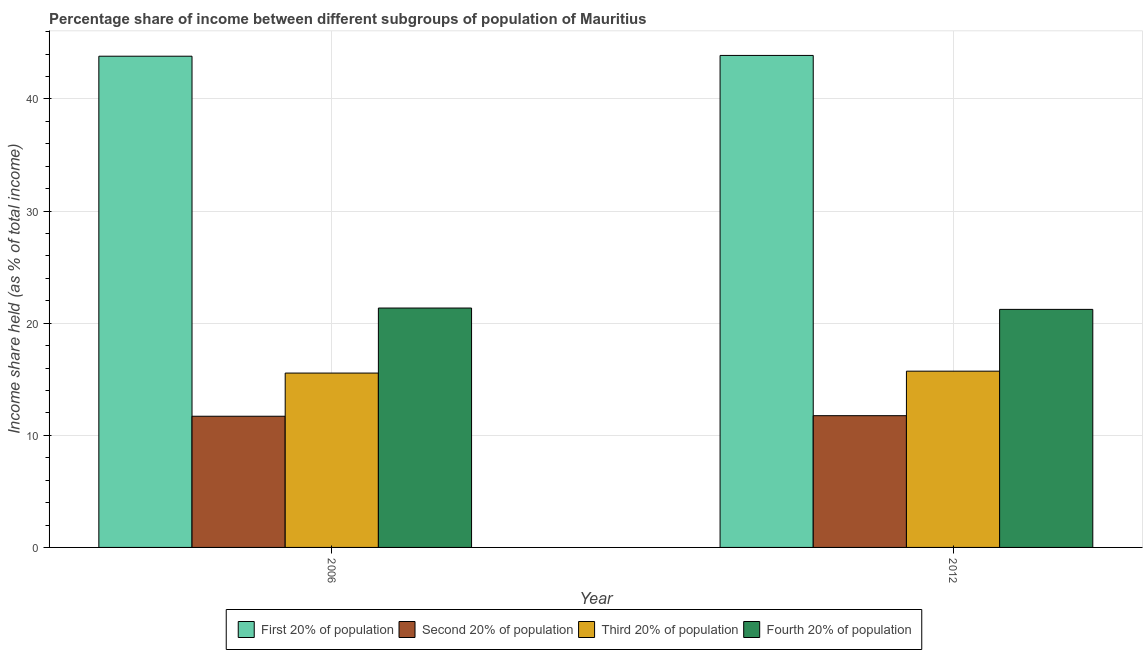How many different coloured bars are there?
Offer a terse response. 4. What is the label of the 1st group of bars from the left?
Provide a succinct answer. 2006. What is the share of the income held by first 20% of the population in 2012?
Keep it short and to the point. 43.88. Across all years, what is the maximum share of the income held by first 20% of the population?
Your response must be concise. 43.88. Across all years, what is the minimum share of the income held by fourth 20% of the population?
Your answer should be very brief. 21.23. In which year was the share of the income held by second 20% of the population maximum?
Offer a terse response. 2012. In which year was the share of the income held by fourth 20% of the population minimum?
Your response must be concise. 2012. What is the total share of the income held by first 20% of the population in the graph?
Offer a very short reply. 87.69. What is the difference between the share of the income held by first 20% of the population in 2006 and that in 2012?
Your answer should be compact. -0.07. What is the difference between the share of the income held by fourth 20% of the population in 2012 and the share of the income held by third 20% of the population in 2006?
Your answer should be compact. -0.12. What is the average share of the income held by second 20% of the population per year?
Ensure brevity in your answer.  11.72. In the year 2012, what is the difference between the share of the income held by second 20% of the population and share of the income held by first 20% of the population?
Keep it short and to the point. 0. In how many years, is the share of the income held by third 20% of the population greater than 34 %?
Your answer should be compact. 0. What is the ratio of the share of the income held by second 20% of the population in 2006 to that in 2012?
Keep it short and to the point. 1. In how many years, is the share of the income held by third 20% of the population greater than the average share of the income held by third 20% of the population taken over all years?
Offer a terse response. 1. Is it the case that in every year, the sum of the share of the income held by fourth 20% of the population and share of the income held by third 20% of the population is greater than the sum of share of the income held by first 20% of the population and share of the income held by second 20% of the population?
Ensure brevity in your answer.  No. What does the 4th bar from the left in 2006 represents?
Offer a terse response. Fourth 20% of population. What does the 2nd bar from the right in 2012 represents?
Make the answer very short. Third 20% of population. How many bars are there?
Provide a short and direct response. 8. Does the graph contain grids?
Your response must be concise. Yes. Where does the legend appear in the graph?
Provide a succinct answer. Bottom center. How many legend labels are there?
Provide a succinct answer. 4. How are the legend labels stacked?
Give a very brief answer. Horizontal. What is the title of the graph?
Keep it short and to the point. Percentage share of income between different subgroups of population of Mauritius. What is the label or title of the Y-axis?
Keep it short and to the point. Income share held (as % of total income). What is the Income share held (as % of total income) in First 20% of population in 2006?
Ensure brevity in your answer.  43.81. What is the Income share held (as % of total income) in Third 20% of population in 2006?
Give a very brief answer. 15.55. What is the Income share held (as % of total income) of Fourth 20% of population in 2006?
Provide a succinct answer. 21.35. What is the Income share held (as % of total income) in First 20% of population in 2012?
Offer a terse response. 43.88. What is the Income share held (as % of total income) of Second 20% of population in 2012?
Provide a short and direct response. 11.75. What is the Income share held (as % of total income) in Third 20% of population in 2012?
Offer a very short reply. 15.72. What is the Income share held (as % of total income) in Fourth 20% of population in 2012?
Provide a short and direct response. 21.23. Across all years, what is the maximum Income share held (as % of total income) of First 20% of population?
Make the answer very short. 43.88. Across all years, what is the maximum Income share held (as % of total income) of Second 20% of population?
Provide a short and direct response. 11.75. Across all years, what is the maximum Income share held (as % of total income) in Third 20% of population?
Offer a very short reply. 15.72. Across all years, what is the maximum Income share held (as % of total income) in Fourth 20% of population?
Provide a succinct answer. 21.35. Across all years, what is the minimum Income share held (as % of total income) in First 20% of population?
Offer a terse response. 43.81. Across all years, what is the minimum Income share held (as % of total income) in Third 20% of population?
Make the answer very short. 15.55. Across all years, what is the minimum Income share held (as % of total income) of Fourth 20% of population?
Your answer should be very brief. 21.23. What is the total Income share held (as % of total income) in First 20% of population in the graph?
Your answer should be very brief. 87.69. What is the total Income share held (as % of total income) of Second 20% of population in the graph?
Provide a succinct answer. 23.45. What is the total Income share held (as % of total income) in Third 20% of population in the graph?
Make the answer very short. 31.27. What is the total Income share held (as % of total income) of Fourth 20% of population in the graph?
Your answer should be compact. 42.58. What is the difference between the Income share held (as % of total income) in First 20% of population in 2006 and that in 2012?
Offer a very short reply. -0.07. What is the difference between the Income share held (as % of total income) in Third 20% of population in 2006 and that in 2012?
Your answer should be very brief. -0.17. What is the difference between the Income share held (as % of total income) in Fourth 20% of population in 2006 and that in 2012?
Make the answer very short. 0.12. What is the difference between the Income share held (as % of total income) in First 20% of population in 2006 and the Income share held (as % of total income) in Second 20% of population in 2012?
Your answer should be compact. 32.06. What is the difference between the Income share held (as % of total income) of First 20% of population in 2006 and the Income share held (as % of total income) of Third 20% of population in 2012?
Your answer should be very brief. 28.09. What is the difference between the Income share held (as % of total income) in First 20% of population in 2006 and the Income share held (as % of total income) in Fourth 20% of population in 2012?
Offer a terse response. 22.58. What is the difference between the Income share held (as % of total income) in Second 20% of population in 2006 and the Income share held (as % of total income) in Third 20% of population in 2012?
Provide a succinct answer. -4.02. What is the difference between the Income share held (as % of total income) of Second 20% of population in 2006 and the Income share held (as % of total income) of Fourth 20% of population in 2012?
Keep it short and to the point. -9.53. What is the difference between the Income share held (as % of total income) of Third 20% of population in 2006 and the Income share held (as % of total income) of Fourth 20% of population in 2012?
Provide a succinct answer. -5.68. What is the average Income share held (as % of total income) of First 20% of population per year?
Your response must be concise. 43.84. What is the average Income share held (as % of total income) of Second 20% of population per year?
Make the answer very short. 11.72. What is the average Income share held (as % of total income) of Third 20% of population per year?
Ensure brevity in your answer.  15.63. What is the average Income share held (as % of total income) of Fourth 20% of population per year?
Ensure brevity in your answer.  21.29. In the year 2006, what is the difference between the Income share held (as % of total income) of First 20% of population and Income share held (as % of total income) of Second 20% of population?
Ensure brevity in your answer.  32.11. In the year 2006, what is the difference between the Income share held (as % of total income) of First 20% of population and Income share held (as % of total income) of Third 20% of population?
Offer a terse response. 28.26. In the year 2006, what is the difference between the Income share held (as % of total income) of First 20% of population and Income share held (as % of total income) of Fourth 20% of population?
Provide a short and direct response. 22.46. In the year 2006, what is the difference between the Income share held (as % of total income) in Second 20% of population and Income share held (as % of total income) in Third 20% of population?
Provide a short and direct response. -3.85. In the year 2006, what is the difference between the Income share held (as % of total income) of Second 20% of population and Income share held (as % of total income) of Fourth 20% of population?
Give a very brief answer. -9.65. In the year 2006, what is the difference between the Income share held (as % of total income) in Third 20% of population and Income share held (as % of total income) in Fourth 20% of population?
Your response must be concise. -5.8. In the year 2012, what is the difference between the Income share held (as % of total income) of First 20% of population and Income share held (as % of total income) of Second 20% of population?
Ensure brevity in your answer.  32.13. In the year 2012, what is the difference between the Income share held (as % of total income) of First 20% of population and Income share held (as % of total income) of Third 20% of population?
Make the answer very short. 28.16. In the year 2012, what is the difference between the Income share held (as % of total income) in First 20% of population and Income share held (as % of total income) in Fourth 20% of population?
Ensure brevity in your answer.  22.65. In the year 2012, what is the difference between the Income share held (as % of total income) of Second 20% of population and Income share held (as % of total income) of Third 20% of population?
Ensure brevity in your answer.  -3.97. In the year 2012, what is the difference between the Income share held (as % of total income) of Second 20% of population and Income share held (as % of total income) of Fourth 20% of population?
Provide a succinct answer. -9.48. In the year 2012, what is the difference between the Income share held (as % of total income) of Third 20% of population and Income share held (as % of total income) of Fourth 20% of population?
Give a very brief answer. -5.51. What is the ratio of the Income share held (as % of total income) in Second 20% of population in 2006 to that in 2012?
Ensure brevity in your answer.  1. What is the ratio of the Income share held (as % of total income) in Third 20% of population in 2006 to that in 2012?
Provide a succinct answer. 0.99. What is the difference between the highest and the second highest Income share held (as % of total income) of First 20% of population?
Make the answer very short. 0.07. What is the difference between the highest and the second highest Income share held (as % of total income) in Third 20% of population?
Keep it short and to the point. 0.17. What is the difference between the highest and the second highest Income share held (as % of total income) of Fourth 20% of population?
Your answer should be very brief. 0.12. What is the difference between the highest and the lowest Income share held (as % of total income) in First 20% of population?
Provide a short and direct response. 0.07. What is the difference between the highest and the lowest Income share held (as % of total income) in Third 20% of population?
Your answer should be compact. 0.17. What is the difference between the highest and the lowest Income share held (as % of total income) in Fourth 20% of population?
Keep it short and to the point. 0.12. 